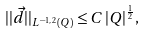Convert formula to latex. <formula><loc_0><loc_0><loc_500><loc_500>| | \vec { d } | | _ { L ^ { - 1 , \, 2 } ( Q ) } \leq C \, | Q | ^ { \frac { 1 } { 2 } } ,</formula> 